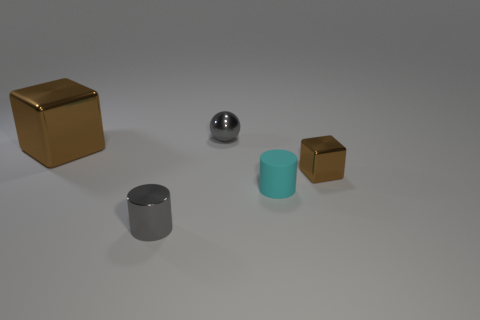Can you compare the textures of the different objects? Certainly! The golden cube has a reflective surface indicating it could be metal; it presents a sharp contrast to the matte finish of the cyan rubber cylinder. The gray cylinder also seems metallic due to its luster, and the small brown cube appears to have a more diffuse reflection, which may suggest a rougher texture, possibly cardboard or a matte-painted surface. 